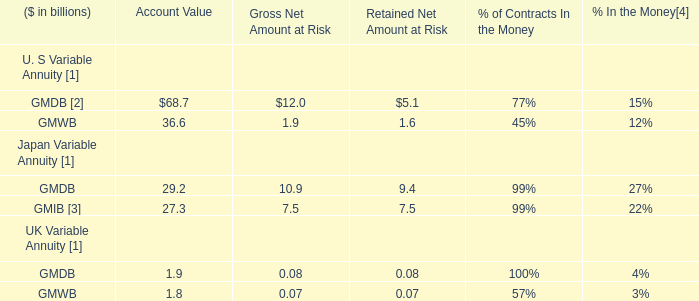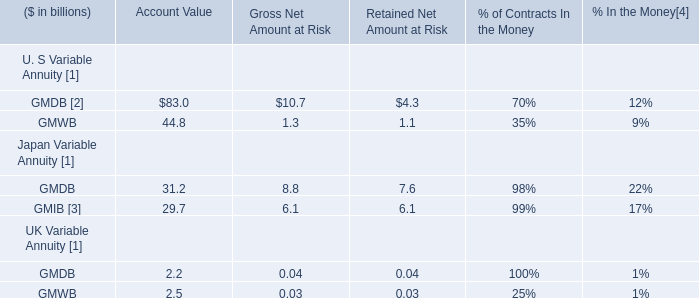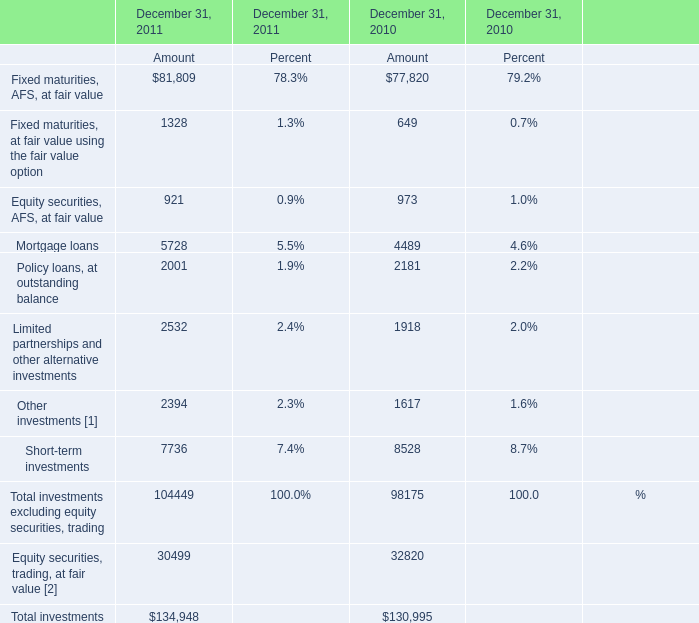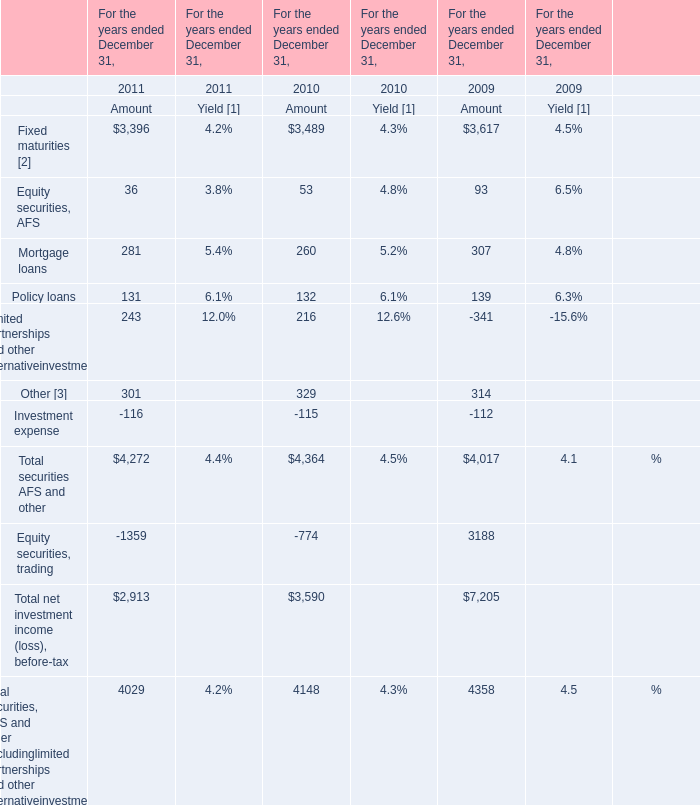What's the current growth rate of Policy loans, at outstanding balance for Amount? 
Computations: ((2001 - 2181) / 2181)
Answer: -0.08253. 